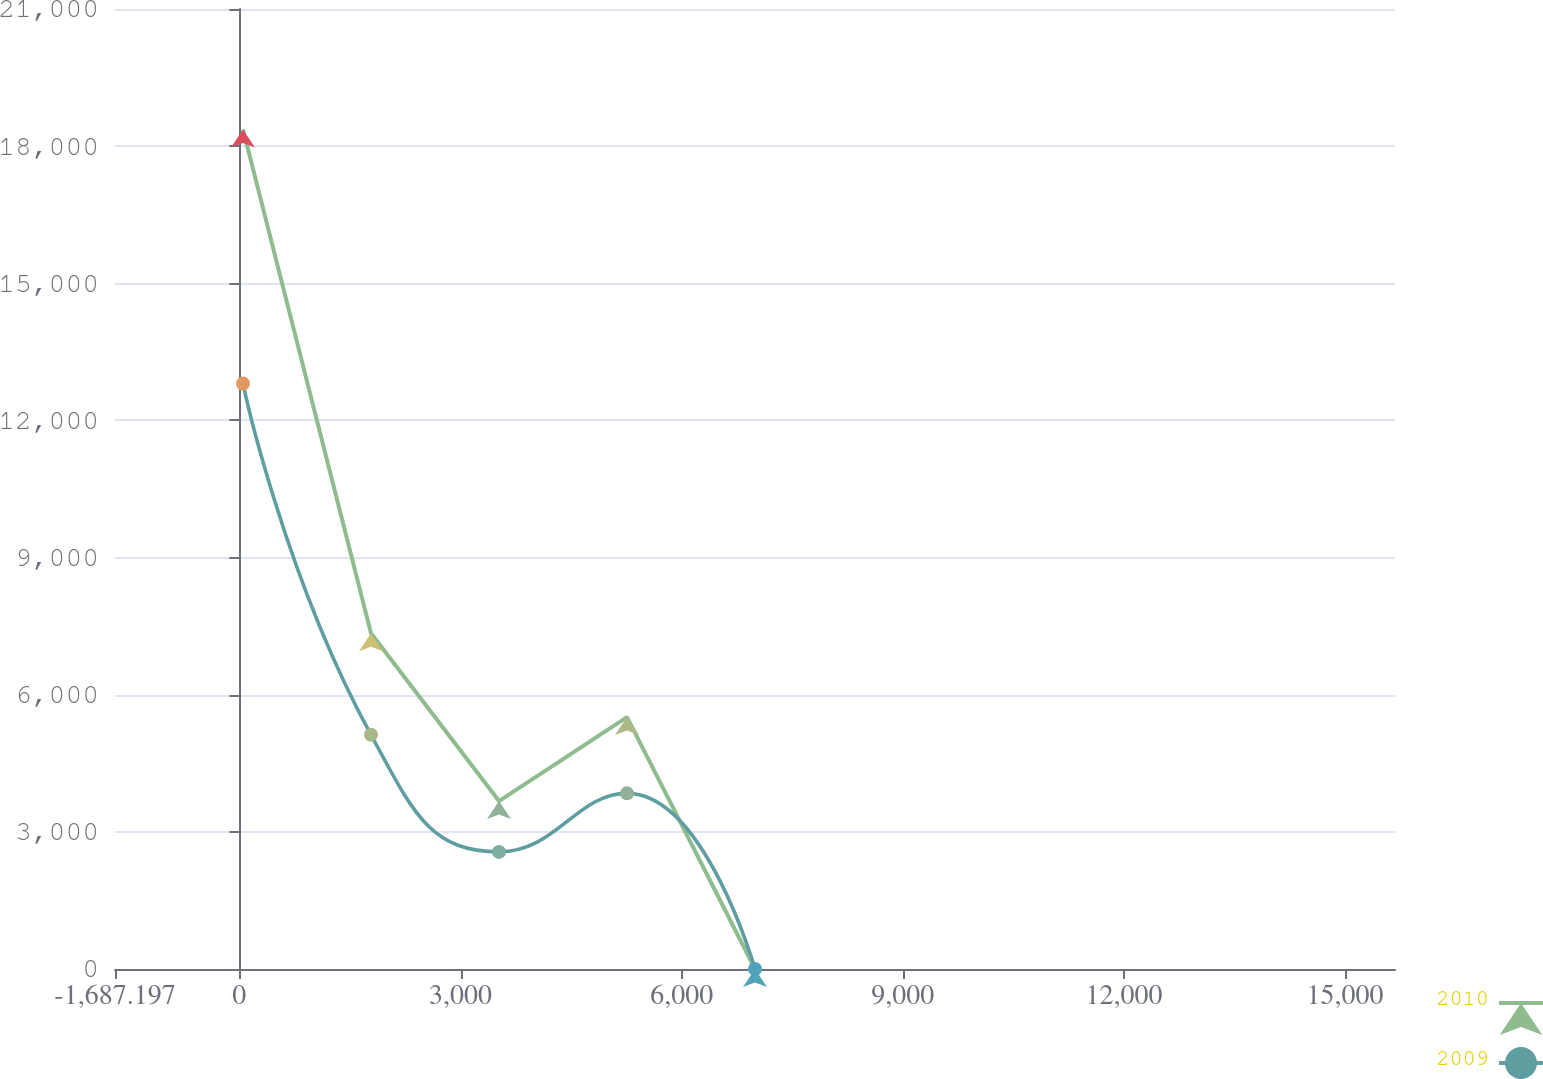Convert chart to OTSL. <chart><loc_0><loc_0><loc_500><loc_500><line_chart><ecel><fcel>2010<fcel>2009<nl><fcel>49.2<fcel>18365<fcel>12805.5<nl><fcel>1785.6<fcel>7346.35<fcel>5122.71<nl><fcel>3522<fcel>3673.49<fcel>2561.79<nl><fcel>5258.4<fcel>5509.92<fcel>3842.25<nl><fcel>6994.8<fcel>0.63<fcel>0.87<nl><fcel>17413.2<fcel>1837.06<fcel>1281.33<nl></chart> 